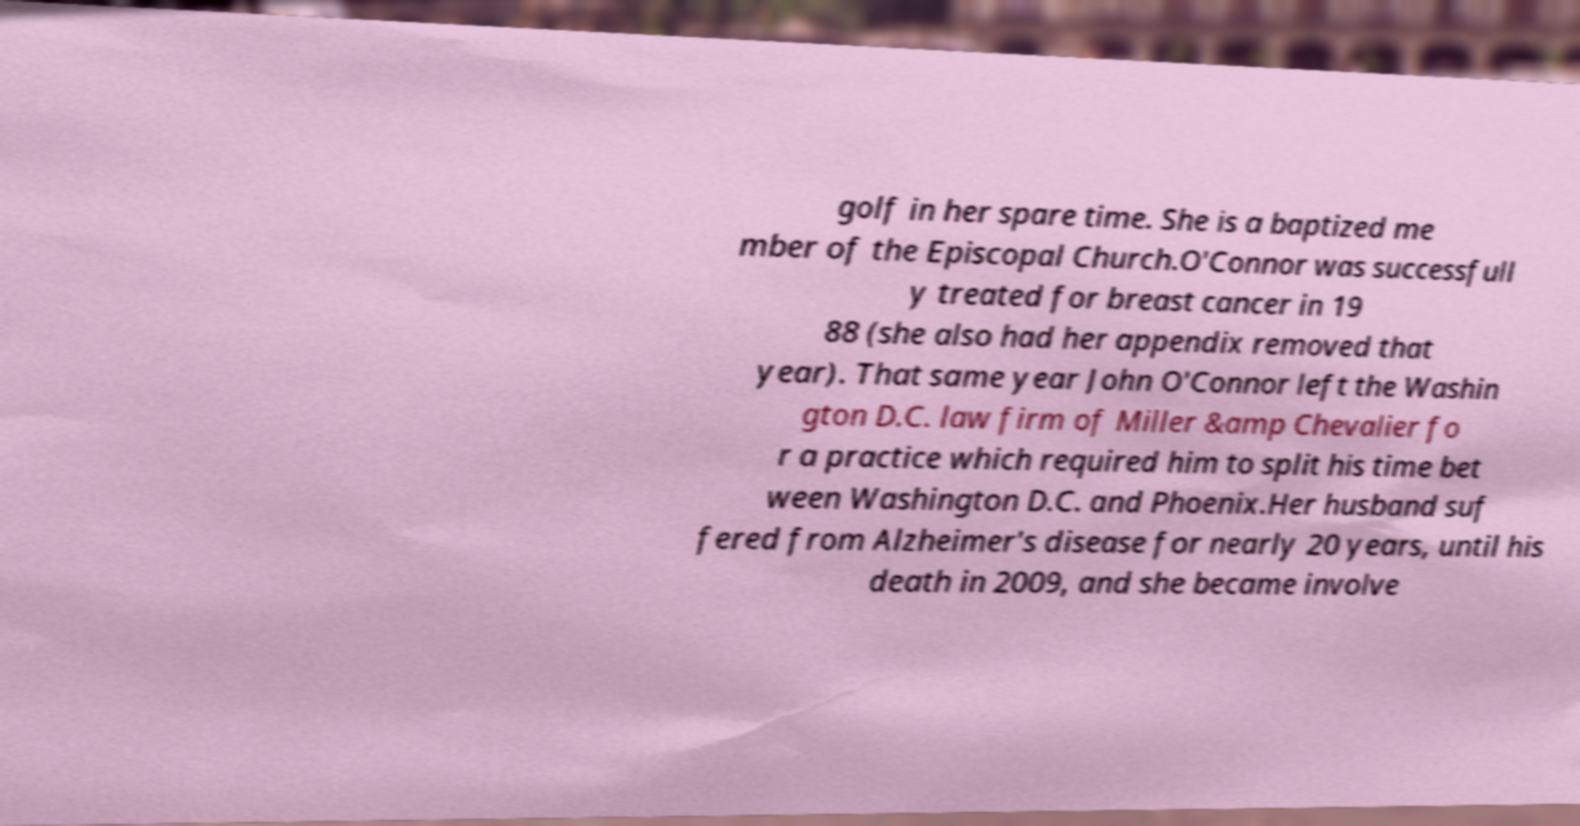Could you extract and type out the text from this image? golf in her spare time. She is a baptized me mber of the Episcopal Church.O'Connor was successfull y treated for breast cancer in 19 88 (she also had her appendix removed that year). That same year John O'Connor left the Washin gton D.C. law firm of Miller &amp Chevalier fo r a practice which required him to split his time bet ween Washington D.C. and Phoenix.Her husband suf fered from Alzheimer's disease for nearly 20 years, until his death in 2009, and she became involve 